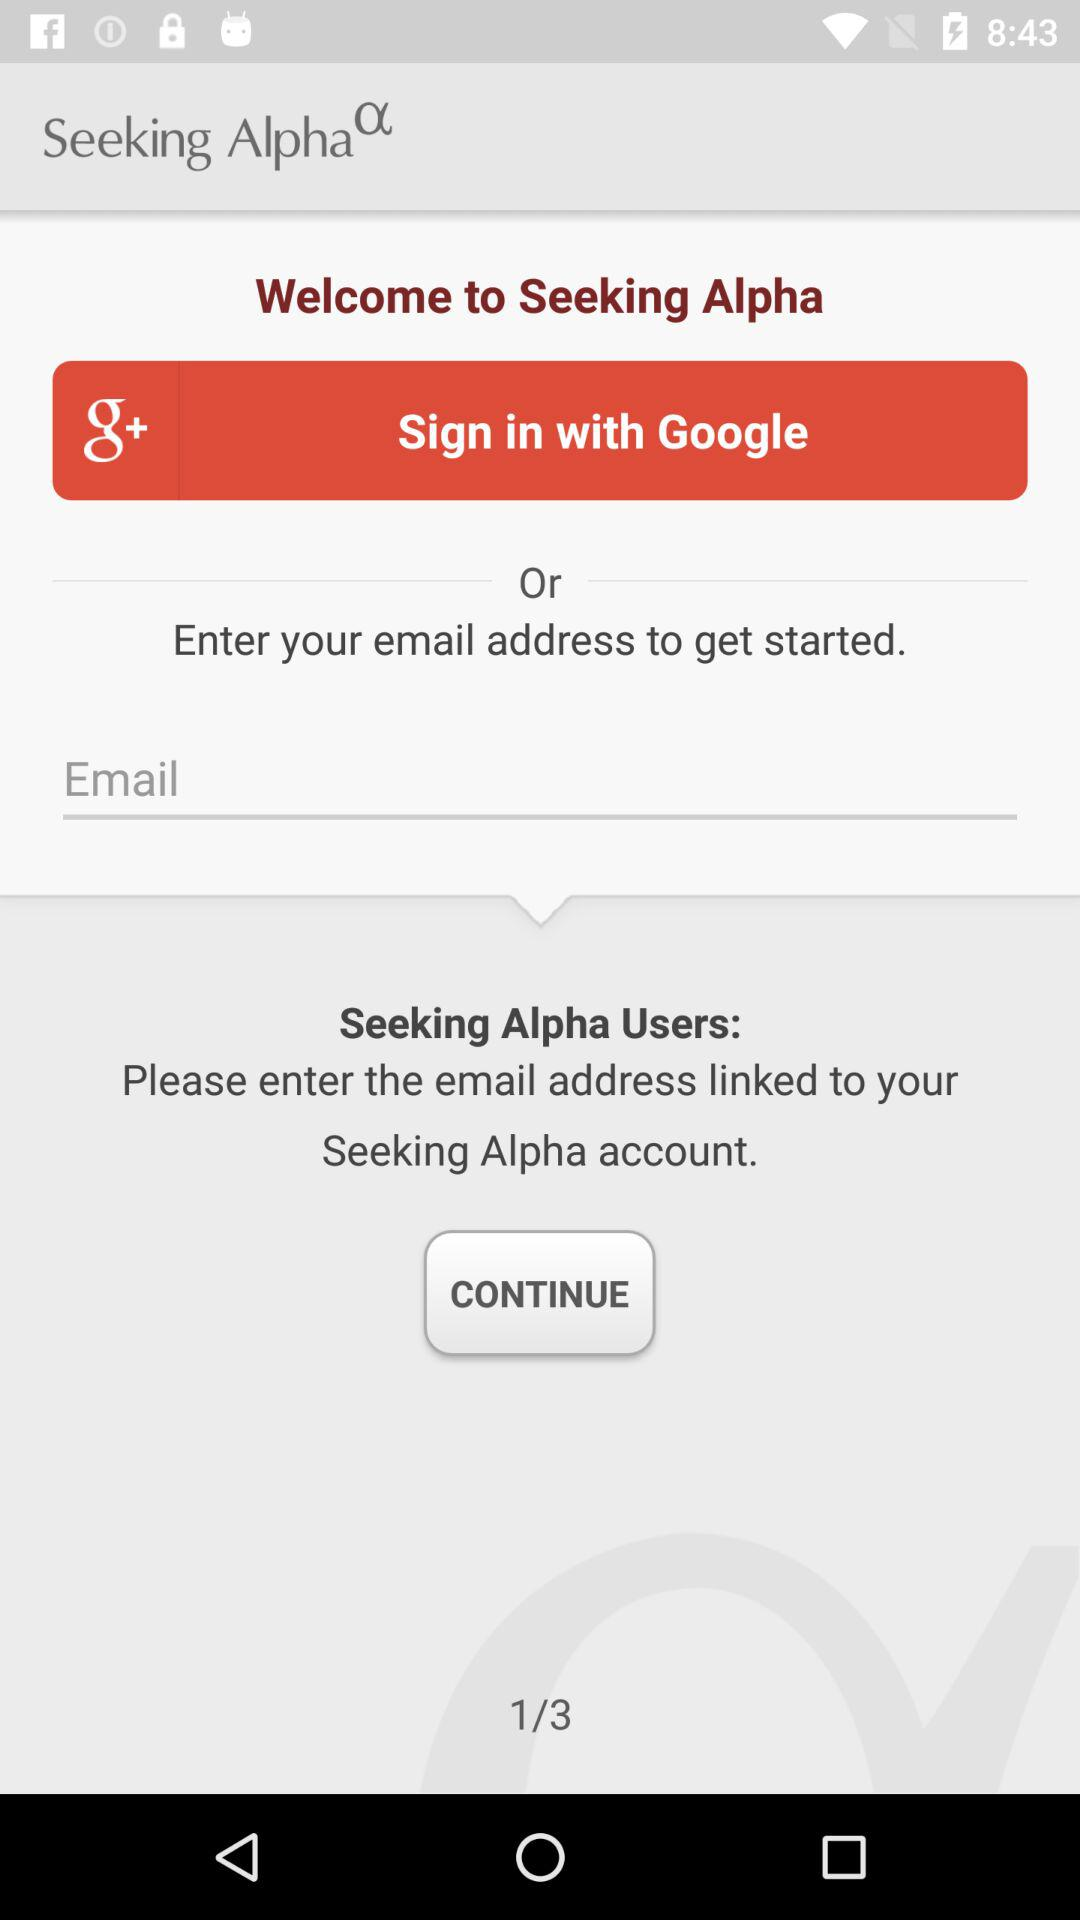What is the entered email address?
When the provided information is insufficient, respond with <no answer>. <no answer> 